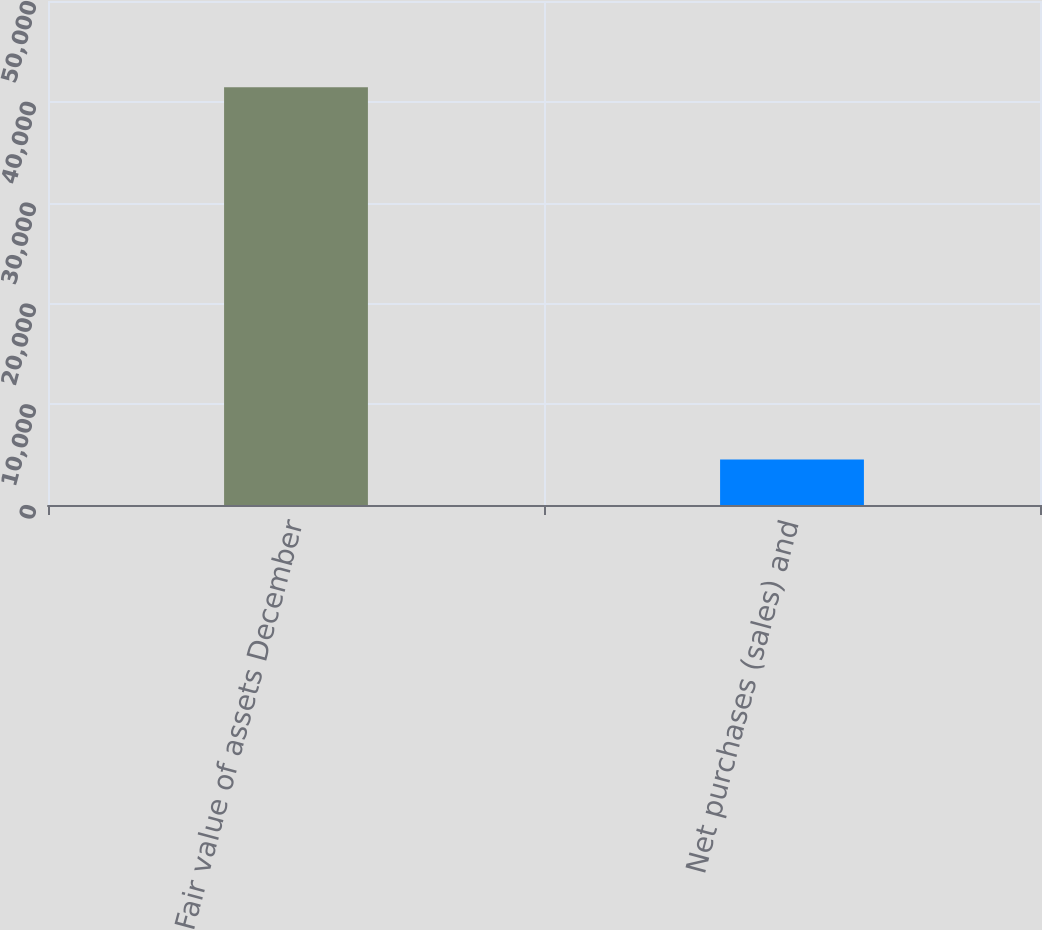<chart> <loc_0><loc_0><loc_500><loc_500><bar_chart><fcel>Fair value of assets December<fcel>Net purchases (sales) and<nl><fcel>41445<fcel>4524<nl></chart> 